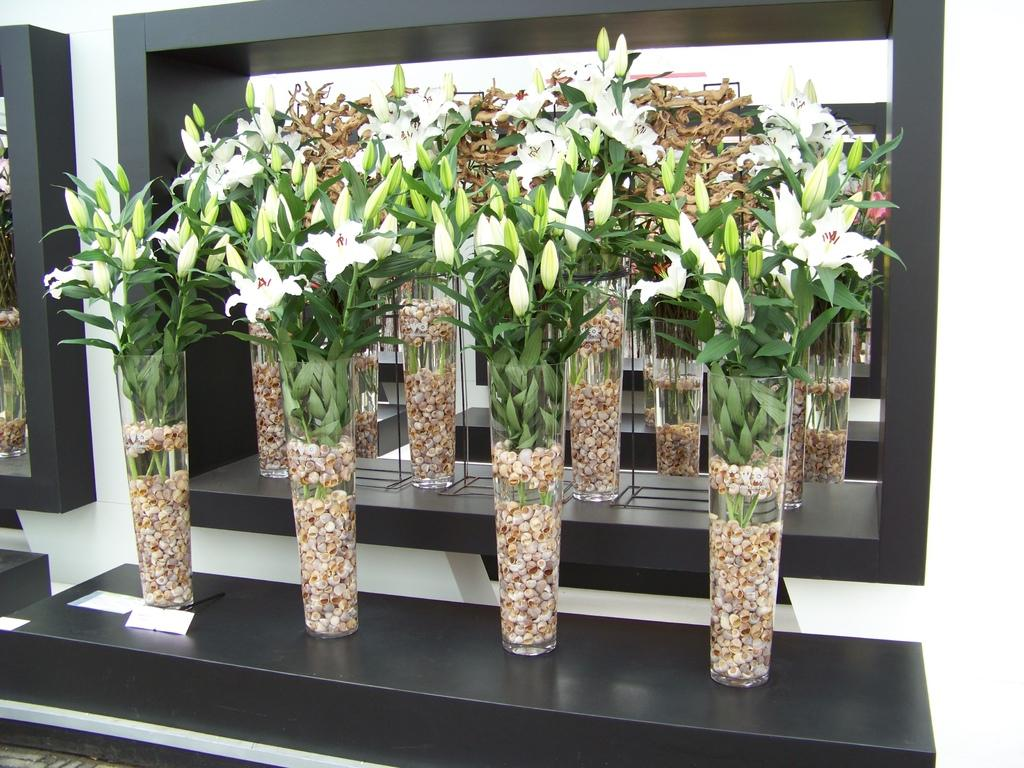What objects are present in the image that hold flowers? There are flower vases in the image. Where are the flower vases located? The flower vases are arranged on shelves. What type of flowers are in the vases? There are white flowers in the vases. What can be seen behind the flower vases? There is a wall visible in the image. How does the nerve system of the flowers affect their growth in the image? There is no mention of a nerve system in the image, as flowers do not have a nervous system. 